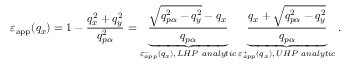Convert formula to latex. <formula><loc_0><loc_0><loc_500><loc_500>{ { \varepsilon } _ { a p p } } ( { { q } _ { x } } ) = 1 - \frac { q _ { x } ^ { 2 } + q _ { y } ^ { 2 } } { q _ { p \alpha } ^ { 2 } } = \underbrace { \frac { \sqrt { q _ { p \alpha } ^ { 2 } - q _ { y } ^ { 2 } } - { { q } _ { x } } } { { { q } _ { p \alpha } } } } _ { \varepsilon _ { a p p } ^ { - } \left ( { { q } _ { x } } \right ) , \, L H P \ a n a l y t i c } \underbrace { \frac { { { q } _ { x } } + \sqrt { q _ { p \alpha } ^ { 2 } - q _ { y } ^ { 2 } } } { { { q } _ { p \alpha } } } } _ { \varepsilon _ { a p p } ^ { + } \left ( { { q } _ { x } } \right ) , \, U H P \ a n a l y t i c } .</formula> 